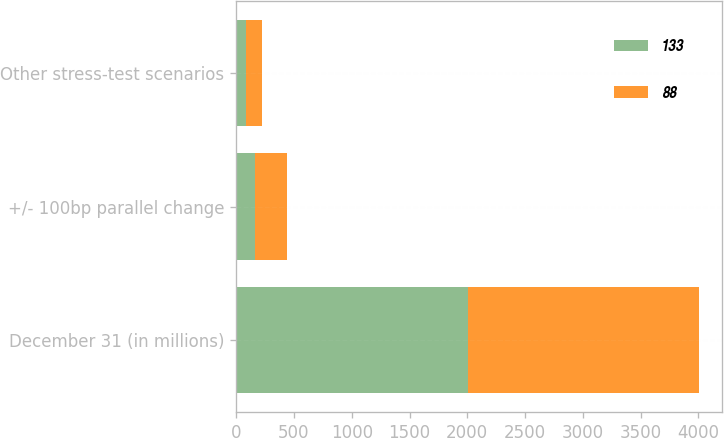<chart> <loc_0><loc_0><loc_500><loc_500><stacked_bar_chart><ecel><fcel>December 31 (in millions)<fcel>+/- 100bp parallel change<fcel>Other stress-test scenarios<nl><fcel>133<fcel>2003<fcel>160<fcel>88<nl><fcel>88<fcel>2002<fcel>277<fcel>133<nl></chart> 